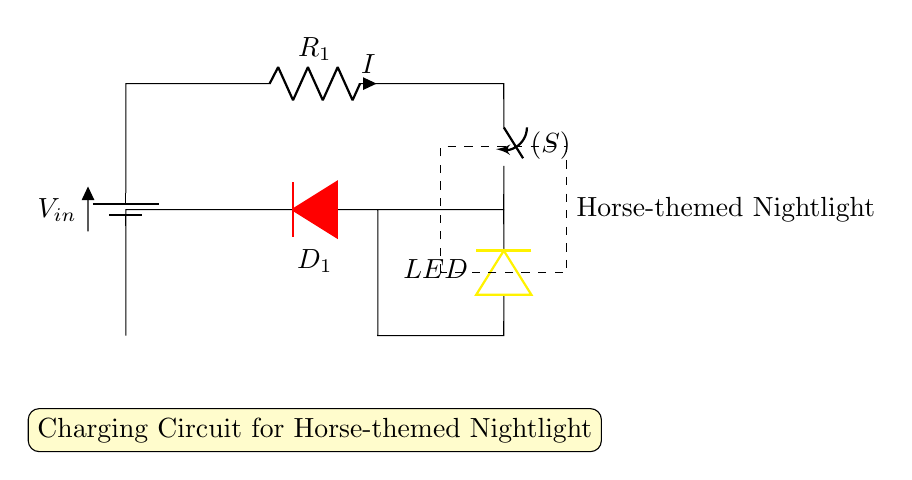What is the type of battery used in this circuit? The circuit shows a symbol for a battery labeled as V_in, indicating it's a direct current (DC) battery. This represents the source of electrical energy for charging the nightlight.
Answer: battery What is the purpose of the resistor in this circuit? The resistor labeled R_1 limits the current flowing through the circuit, protecting other components like the LED and the diode from excessive current, which could cause damage.
Answer: current limiter What does the LED indicate? The LED in the circuit is a light-emitting diode that will light up when the circuit is powered, serving as a visual indicator that the nightlight is functioning.
Answer: light indicator How many main pathways does the circuit have? The circuit shows one primary pathway where the battery feeds current through the resistor to the LED and the diode, making it a simple series circuit.
Answer: one pathway Why is there a diode in the circuit? The diode, labeled D_1, allows current to flow in only one direction, preventing backflow from the LED to the battery, which helps protect the components and ensures proper operation.
Answer: protects components 